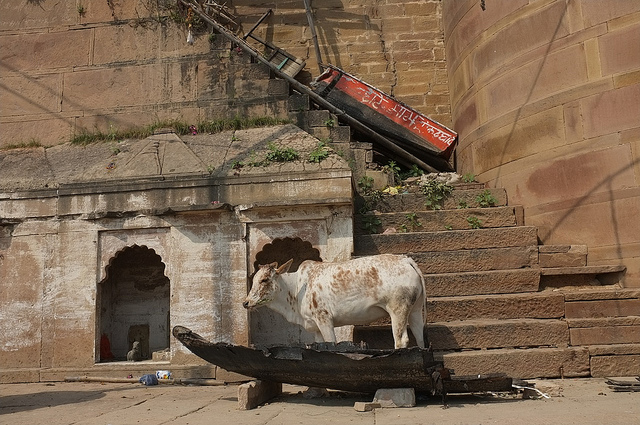What is the cow standing on? The cow is standing on an old, weathered boat, which is quite an unconventional place for a cow to be. 